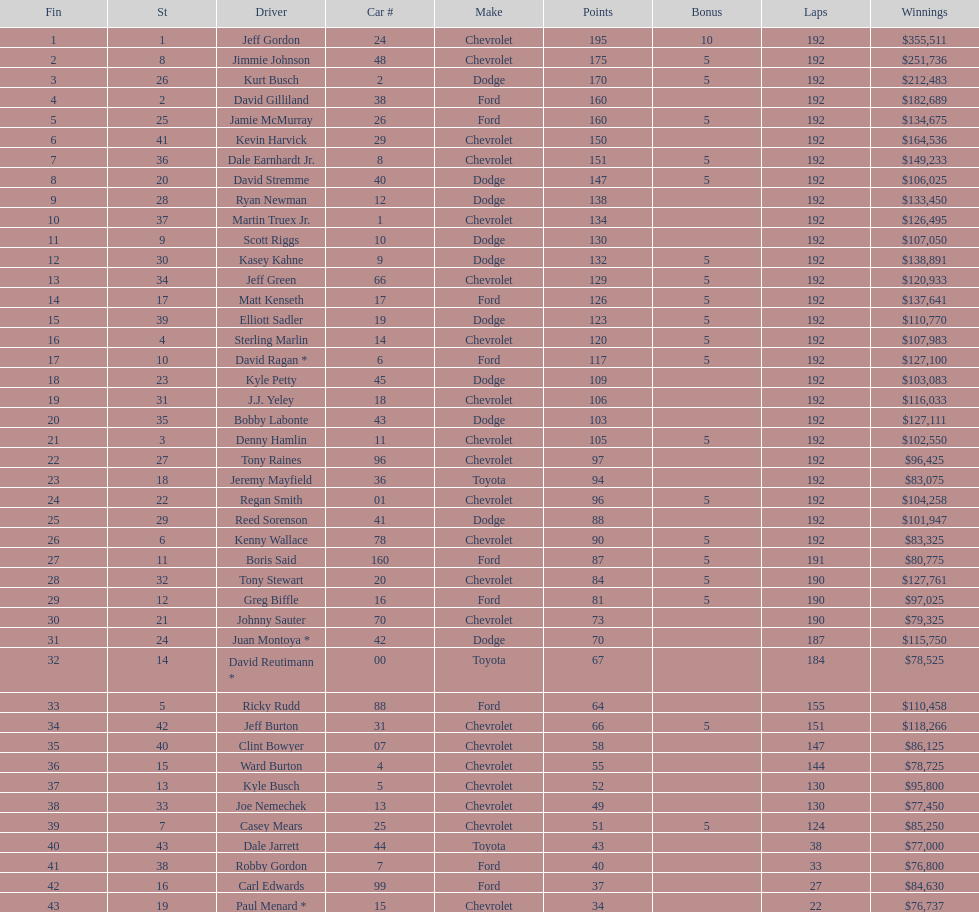Among drivers, who secured the least monetary rewards? Paul Menard *. 